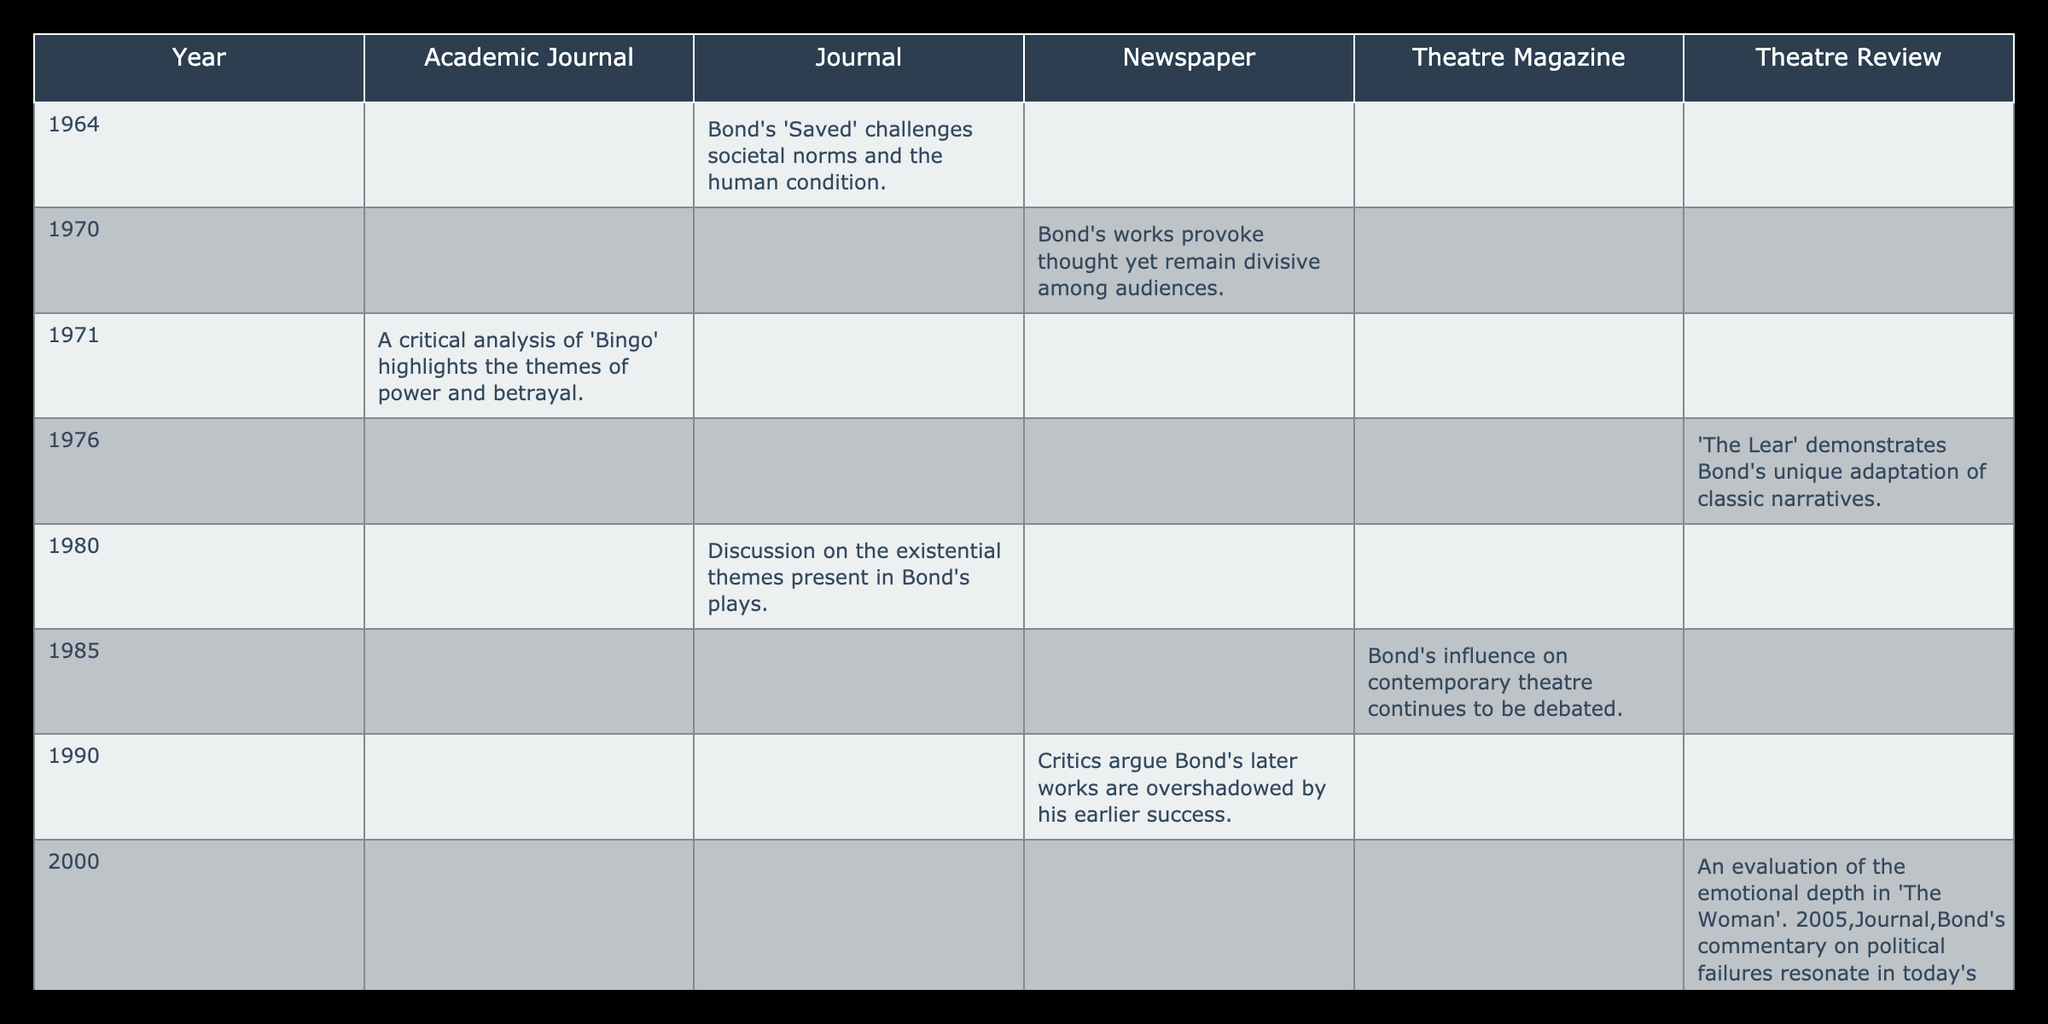What is the critical review for Edward Bond's work in 1980? The table shows that in 1980, the critical review states, "Discussion on the existential themes present in Bond's plays." This is directly listed under the year and publication type.
Answer: Discussion on the existential themes present in Bond's plays How many different publication types are represented in the table? By observing the columns in the table, there are four different publication types: Journal, Newspaper, Academic Journal, Theatre Review, and Theatre Magazine. Counting these types gives a total of five.
Answer: Five What publication type had the most critical reviews in the table? By analyzing the counts of reviews across publication types, we see that the Newspaper has critical reviews from the years 1970, 1990, 2015, which yields a total of three. In contrast, other types either have fewer or the same amount of reviews (e.g., Journals have three as well). However, considering both equal counts, the question prompts us to select the first one alphabetically.
Answer: Newspaper Is there a critical review for an Edward Bond's work published in 2000? Checking the table, there is a critical review listed under the year 2000, stating, "An evaluation of the emotional depth in 'The Woman'." Thus, the answer to the question is yes.
Answer: Yes Which year had the critical review that describes Bond's influence on contemporary theatre? The table marks that the year 1985 contains the critical review "Bond's influence on contemporary theatre continues to be debated." Therefore, the answer is 1985.
Answer: 1985 What is the average number of critical reviews per publication type? By counting the total number of critical reviews (12) and the number of unique publication types (5), we can find the average by dividing: 12 reviews / 5 publication types = 2.4. This numeral represents the average.
Answer: 2.4 Which years contain critical reviews from Theatre Reviews? The table shows that the years which have critical reviews from Theatre Reviews are 1976 and 2000, as those are the only years listed under that publication type.
Answer: 1976, 2000 Was there a critical review for Bond's work in the year 2010? The table indicates a review present for the year 2010, stating, "A retrospective look at how Bond’s work reflects societal changes over time." Thus, the response to whether there was a review for that year is confirmed as yes.
Answer: Yes Which year has the critical review that evaluates 'The Last of the Five'? According to the table, the year 2020 has the critical review, "'The Last of the Five' seen as a culmination of Bond's thematic explorations." This is the only year in the table that mentions this work.
Answer: 2020 How many total critical reviews mentioned political themes? By examining the reviews in the table, there are two reviews that mention political themes: 2005's review, "Bond's commentary on political failures resonate in today's context," and none else. Therefore, the total is one.
Answer: One 